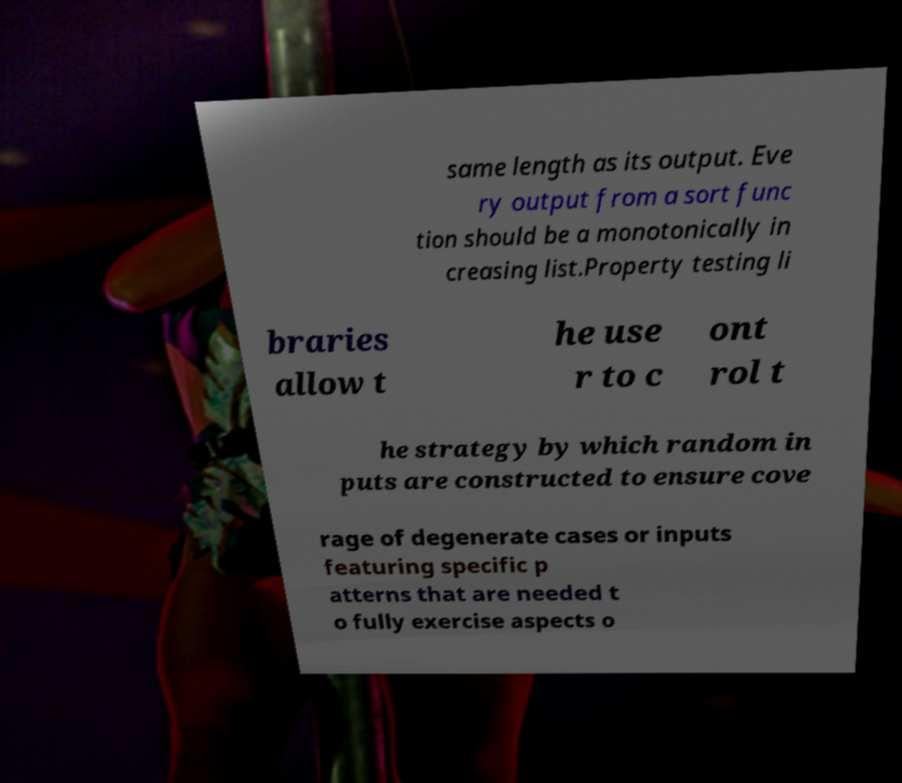Can you read and provide the text displayed in the image?This photo seems to have some interesting text. Can you extract and type it out for me? same length as its output. Eve ry output from a sort func tion should be a monotonically in creasing list.Property testing li braries allow t he use r to c ont rol t he strategy by which random in puts are constructed to ensure cove rage of degenerate cases or inputs featuring specific p atterns that are needed t o fully exercise aspects o 